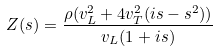<formula> <loc_0><loc_0><loc_500><loc_500>Z ( s ) = \frac { \rho ( v _ { L } ^ { 2 } + 4 v _ { T } ^ { 2 } ( i s - s ^ { 2 } ) ) } { v _ { L } ( 1 + i s ) }</formula> 